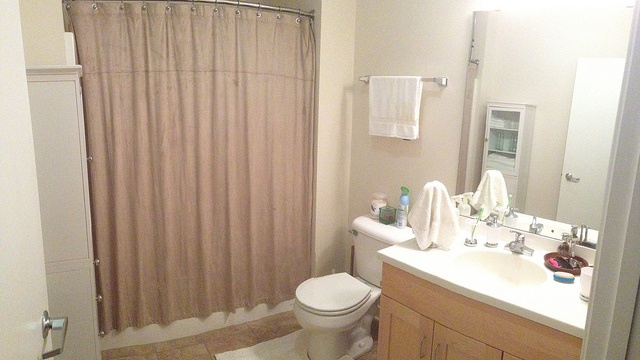Describe the objects in this image and their specific colors. I can see toilet in lightgray, darkgray, and gray tones, sink in lightgray, ivory, darkgray, and gray tones, cup in lightgray, ivory, and darkgray tones, cup in lightgray, darkgray, and gray tones, and cup in lightgray, gray, and darkgray tones in this image. 